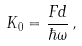<formula> <loc_0><loc_0><loc_500><loc_500>K _ { 0 } = \frac { F d } { \hbar { \omega } } \, ,</formula> 